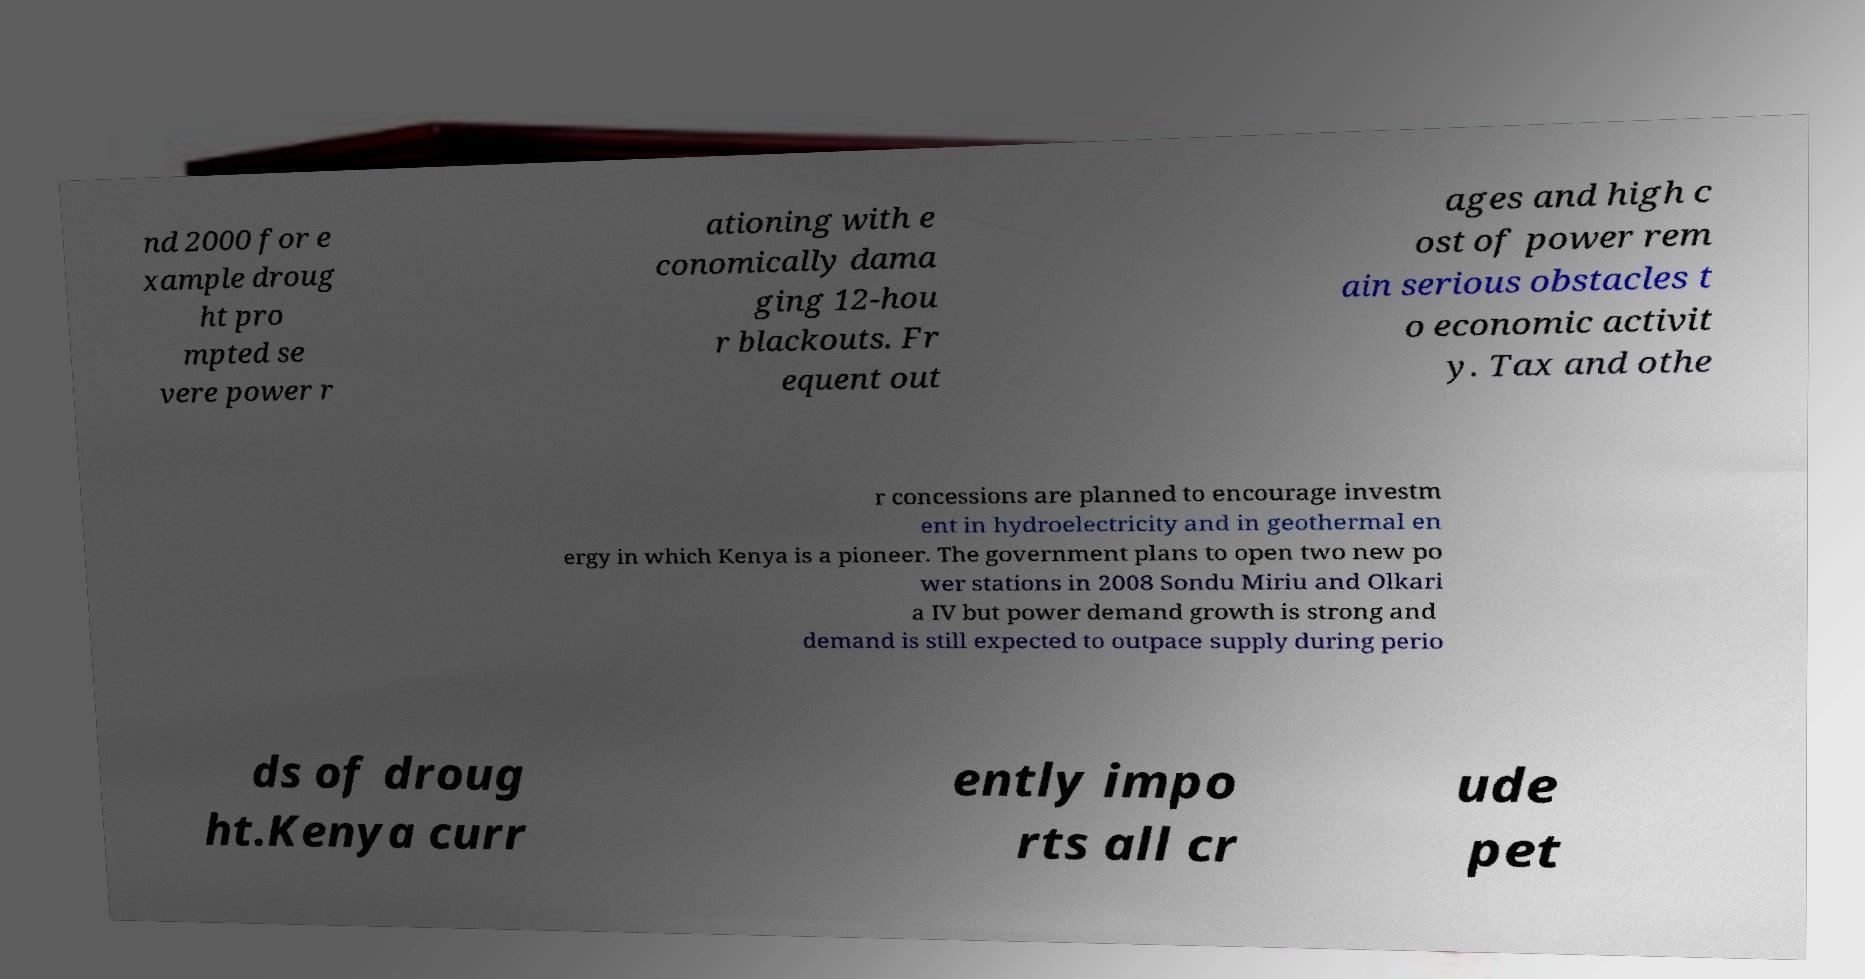What messages or text are displayed in this image? I need them in a readable, typed format. nd 2000 for e xample droug ht pro mpted se vere power r ationing with e conomically dama ging 12-hou r blackouts. Fr equent out ages and high c ost of power rem ain serious obstacles t o economic activit y. Tax and othe r concessions are planned to encourage investm ent in hydroelectricity and in geothermal en ergy in which Kenya is a pioneer. The government plans to open two new po wer stations in 2008 Sondu Miriu and Olkari a IV but power demand growth is strong and demand is still expected to outpace supply during perio ds of droug ht.Kenya curr ently impo rts all cr ude pet 